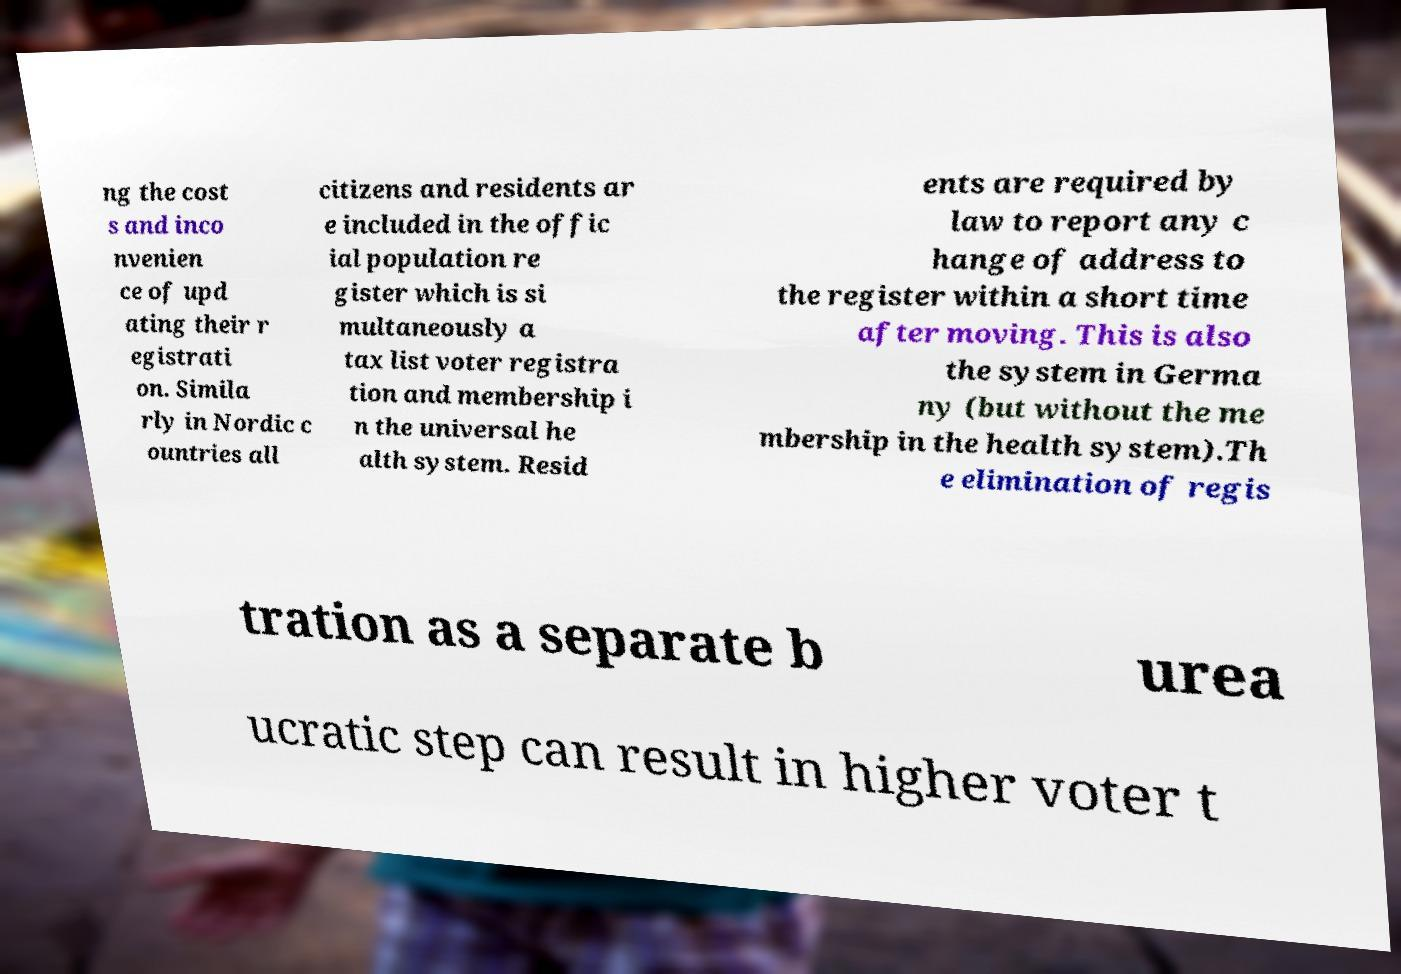I need the written content from this picture converted into text. Can you do that? ng the cost s and inco nvenien ce of upd ating their r egistrati on. Simila rly in Nordic c ountries all citizens and residents ar e included in the offic ial population re gister which is si multaneously a tax list voter registra tion and membership i n the universal he alth system. Resid ents are required by law to report any c hange of address to the register within a short time after moving. This is also the system in Germa ny (but without the me mbership in the health system).Th e elimination of regis tration as a separate b urea ucratic step can result in higher voter t 